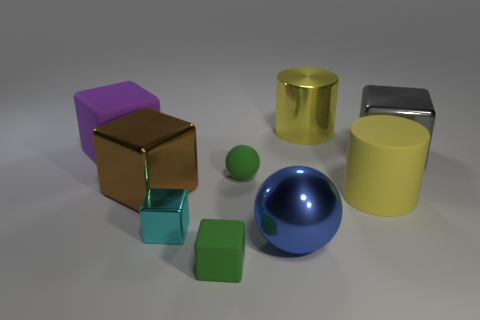Subtract all purple matte blocks. How many blocks are left? 4 Subtract all gray blocks. How many blocks are left? 4 Subtract 1 blocks. How many blocks are left? 4 Add 1 large cyan shiny balls. How many objects exist? 10 Subtract all balls. How many objects are left? 7 Subtract all blue blocks. Subtract all red cylinders. How many blocks are left? 5 Add 9 rubber cylinders. How many rubber cylinders are left? 10 Add 2 large purple balls. How many large purple balls exist? 2 Subtract 0 cyan cylinders. How many objects are left? 9 Subtract all gray matte things. Subtract all big blue balls. How many objects are left? 8 